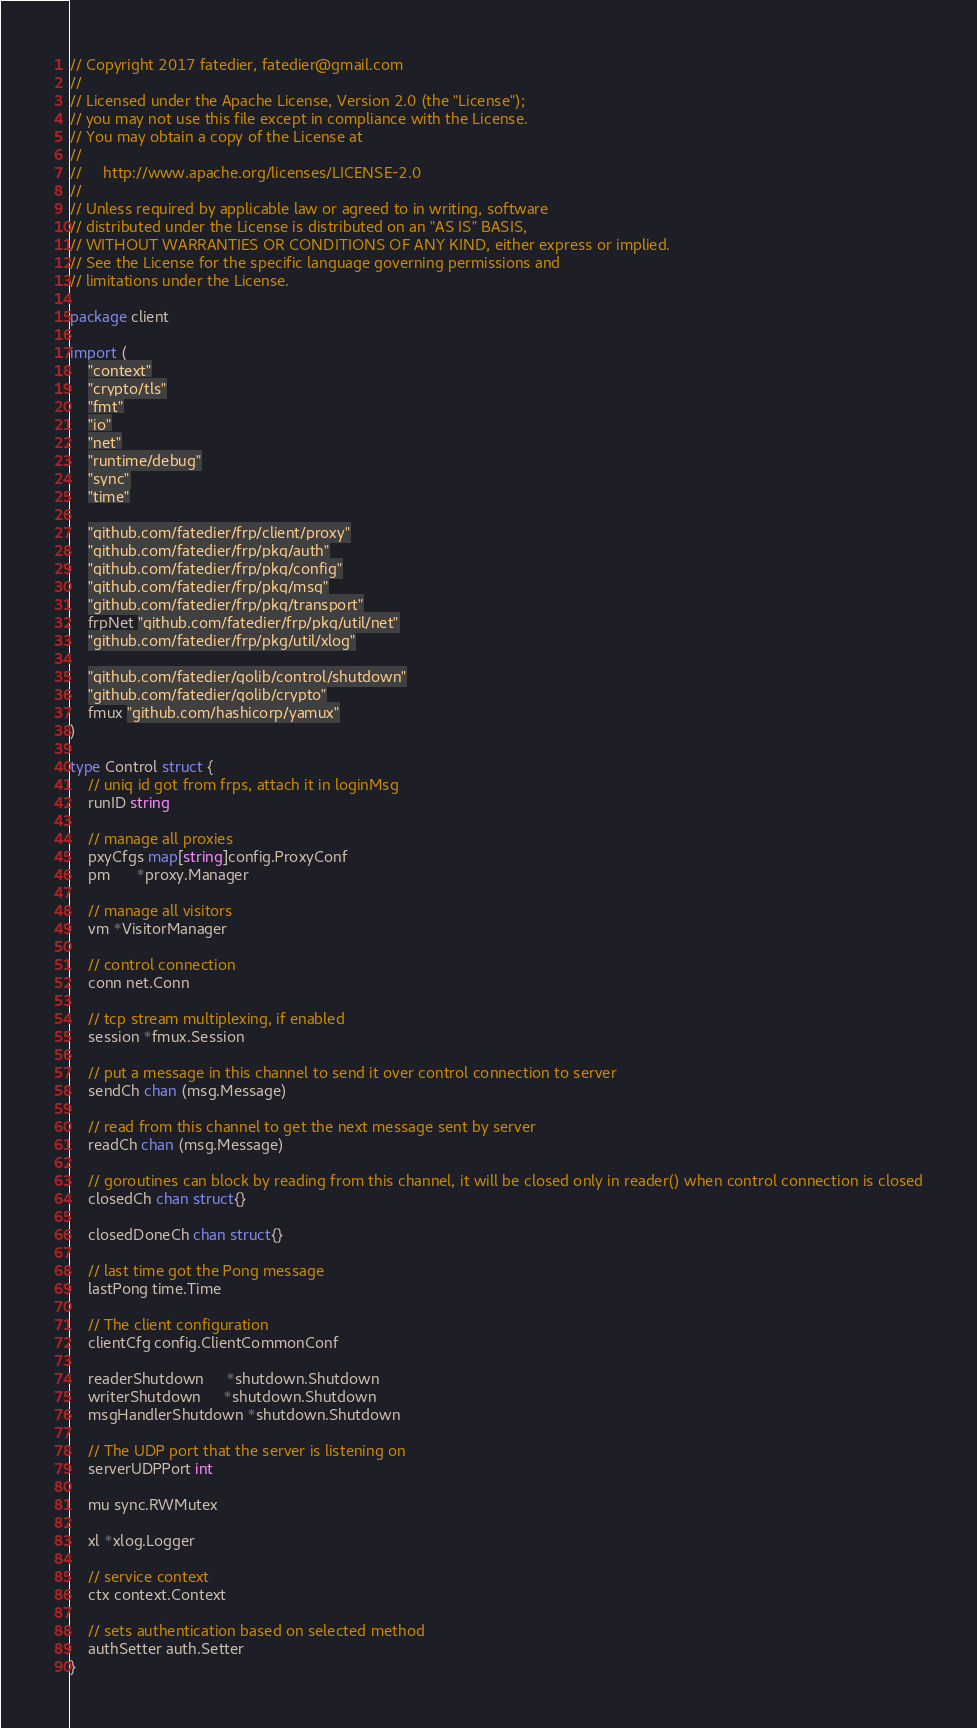<code> <loc_0><loc_0><loc_500><loc_500><_Go_>// Copyright 2017 fatedier, fatedier@gmail.com
//
// Licensed under the Apache License, Version 2.0 (the "License");
// you may not use this file except in compliance with the License.
// You may obtain a copy of the License at
//
//     http://www.apache.org/licenses/LICENSE-2.0
//
// Unless required by applicable law or agreed to in writing, software
// distributed under the License is distributed on an "AS IS" BASIS,
// WITHOUT WARRANTIES OR CONDITIONS OF ANY KIND, either express or implied.
// See the License for the specific language governing permissions and
// limitations under the License.

package client

import (
	"context"
	"crypto/tls"
	"fmt"
	"io"
	"net"
	"runtime/debug"
	"sync"
	"time"

	"github.com/fatedier/frp/client/proxy"
	"github.com/fatedier/frp/pkg/auth"
	"github.com/fatedier/frp/pkg/config"
	"github.com/fatedier/frp/pkg/msg"
	"github.com/fatedier/frp/pkg/transport"
	frpNet "github.com/fatedier/frp/pkg/util/net"
	"github.com/fatedier/frp/pkg/util/xlog"

	"github.com/fatedier/golib/control/shutdown"
	"github.com/fatedier/golib/crypto"
	fmux "github.com/hashicorp/yamux"
)

type Control struct {
	// uniq id got from frps, attach it in loginMsg
	runID string

	// manage all proxies
	pxyCfgs map[string]config.ProxyConf
	pm      *proxy.Manager

	// manage all visitors
	vm *VisitorManager

	// control connection
	conn net.Conn

	// tcp stream multiplexing, if enabled
	session *fmux.Session

	// put a message in this channel to send it over control connection to server
	sendCh chan (msg.Message)

	// read from this channel to get the next message sent by server
	readCh chan (msg.Message)

	// goroutines can block by reading from this channel, it will be closed only in reader() when control connection is closed
	closedCh chan struct{}

	closedDoneCh chan struct{}

	// last time got the Pong message
	lastPong time.Time

	// The client configuration
	clientCfg config.ClientCommonConf

	readerShutdown     *shutdown.Shutdown
	writerShutdown     *shutdown.Shutdown
	msgHandlerShutdown *shutdown.Shutdown

	// The UDP port that the server is listening on
	serverUDPPort int

	mu sync.RWMutex

	xl *xlog.Logger

	// service context
	ctx context.Context

	// sets authentication based on selected method
	authSetter auth.Setter
}
</code> 